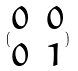Convert formula to latex. <formula><loc_0><loc_0><loc_500><loc_500>( \begin{matrix} 0 & 0 \\ 0 & 1 \end{matrix} )</formula> 